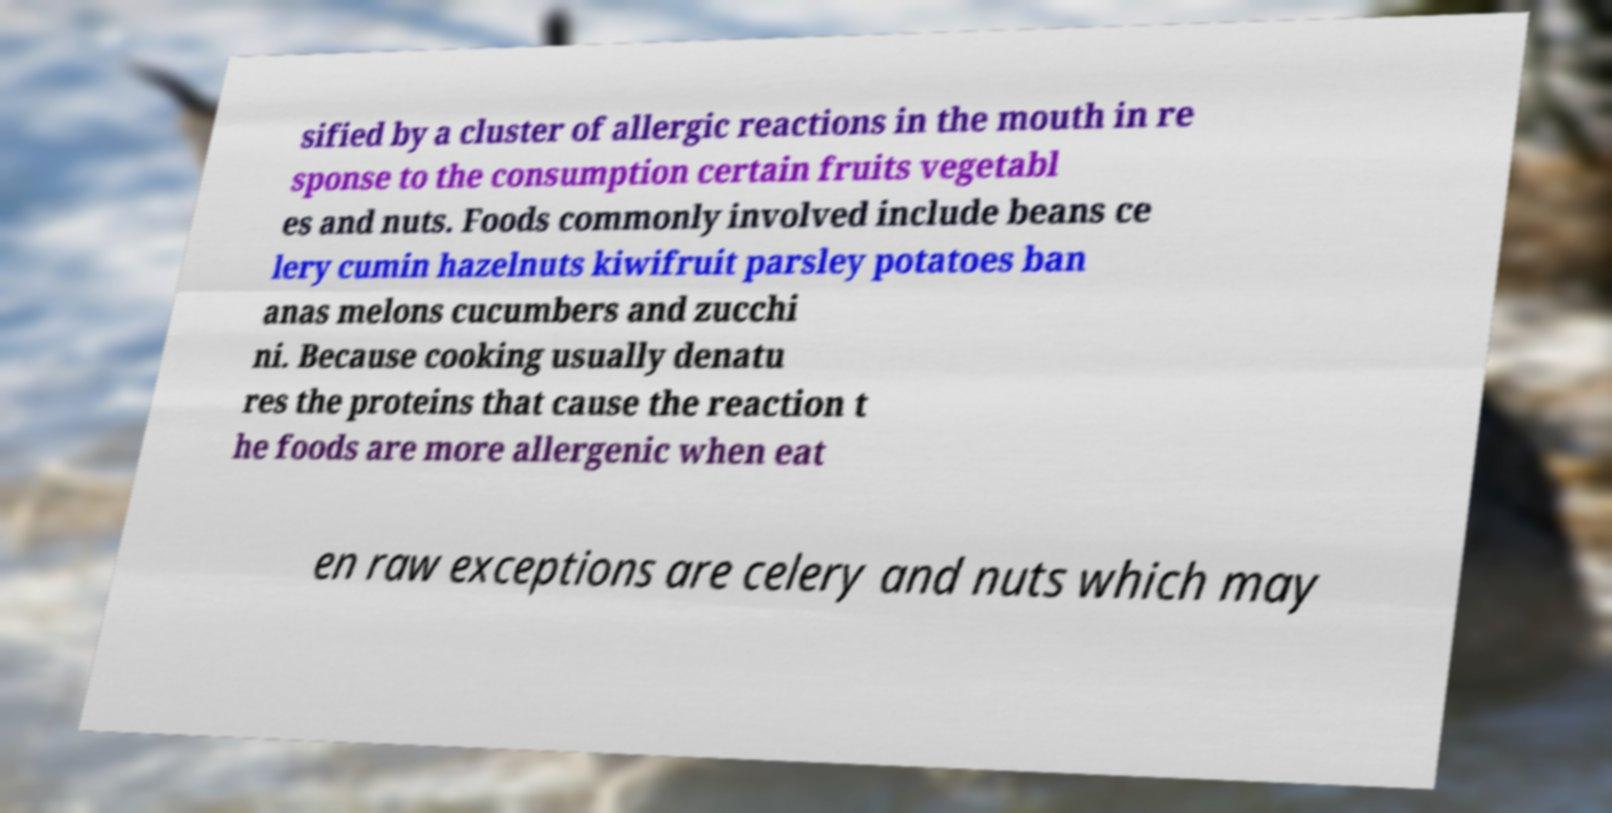I need the written content from this picture converted into text. Can you do that? sified by a cluster of allergic reactions in the mouth in re sponse to the consumption certain fruits vegetabl es and nuts. Foods commonly involved include beans ce lery cumin hazelnuts kiwifruit parsley potatoes ban anas melons cucumbers and zucchi ni. Because cooking usually denatu res the proteins that cause the reaction t he foods are more allergenic when eat en raw exceptions are celery and nuts which may 